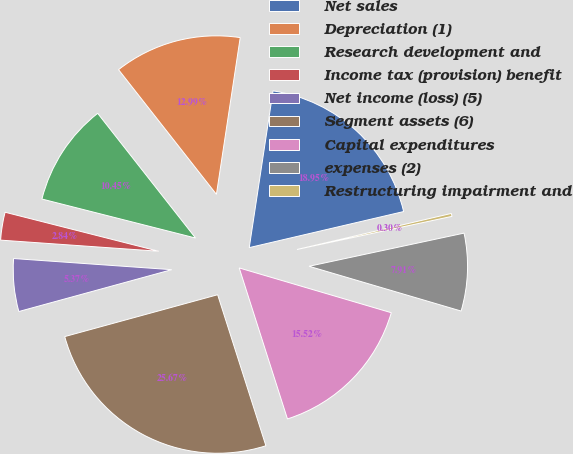Convert chart. <chart><loc_0><loc_0><loc_500><loc_500><pie_chart><fcel>Net sales<fcel>Depreciation (1)<fcel>Research development and<fcel>Income tax (provision) benefit<fcel>Net income (loss) (5)<fcel>Segment assets (6)<fcel>Capital expenditures<fcel>expenses (2)<fcel>Restructuring impairment and<nl><fcel>18.95%<fcel>12.99%<fcel>10.45%<fcel>2.84%<fcel>5.37%<fcel>25.67%<fcel>15.52%<fcel>7.91%<fcel>0.3%<nl></chart> 